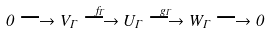<formula> <loc_0><loc_0><loc_500><loc_500>0 \longrightarrow V _ { \Gamma } \stackrel { f _ { \Gamma } } { \longrightarrow } U _ { \Gamma } \stackrel { g _ { \Gamma } } { \longrightarrow } W _ { \Gamma } \longrightarrow 0</formula> 